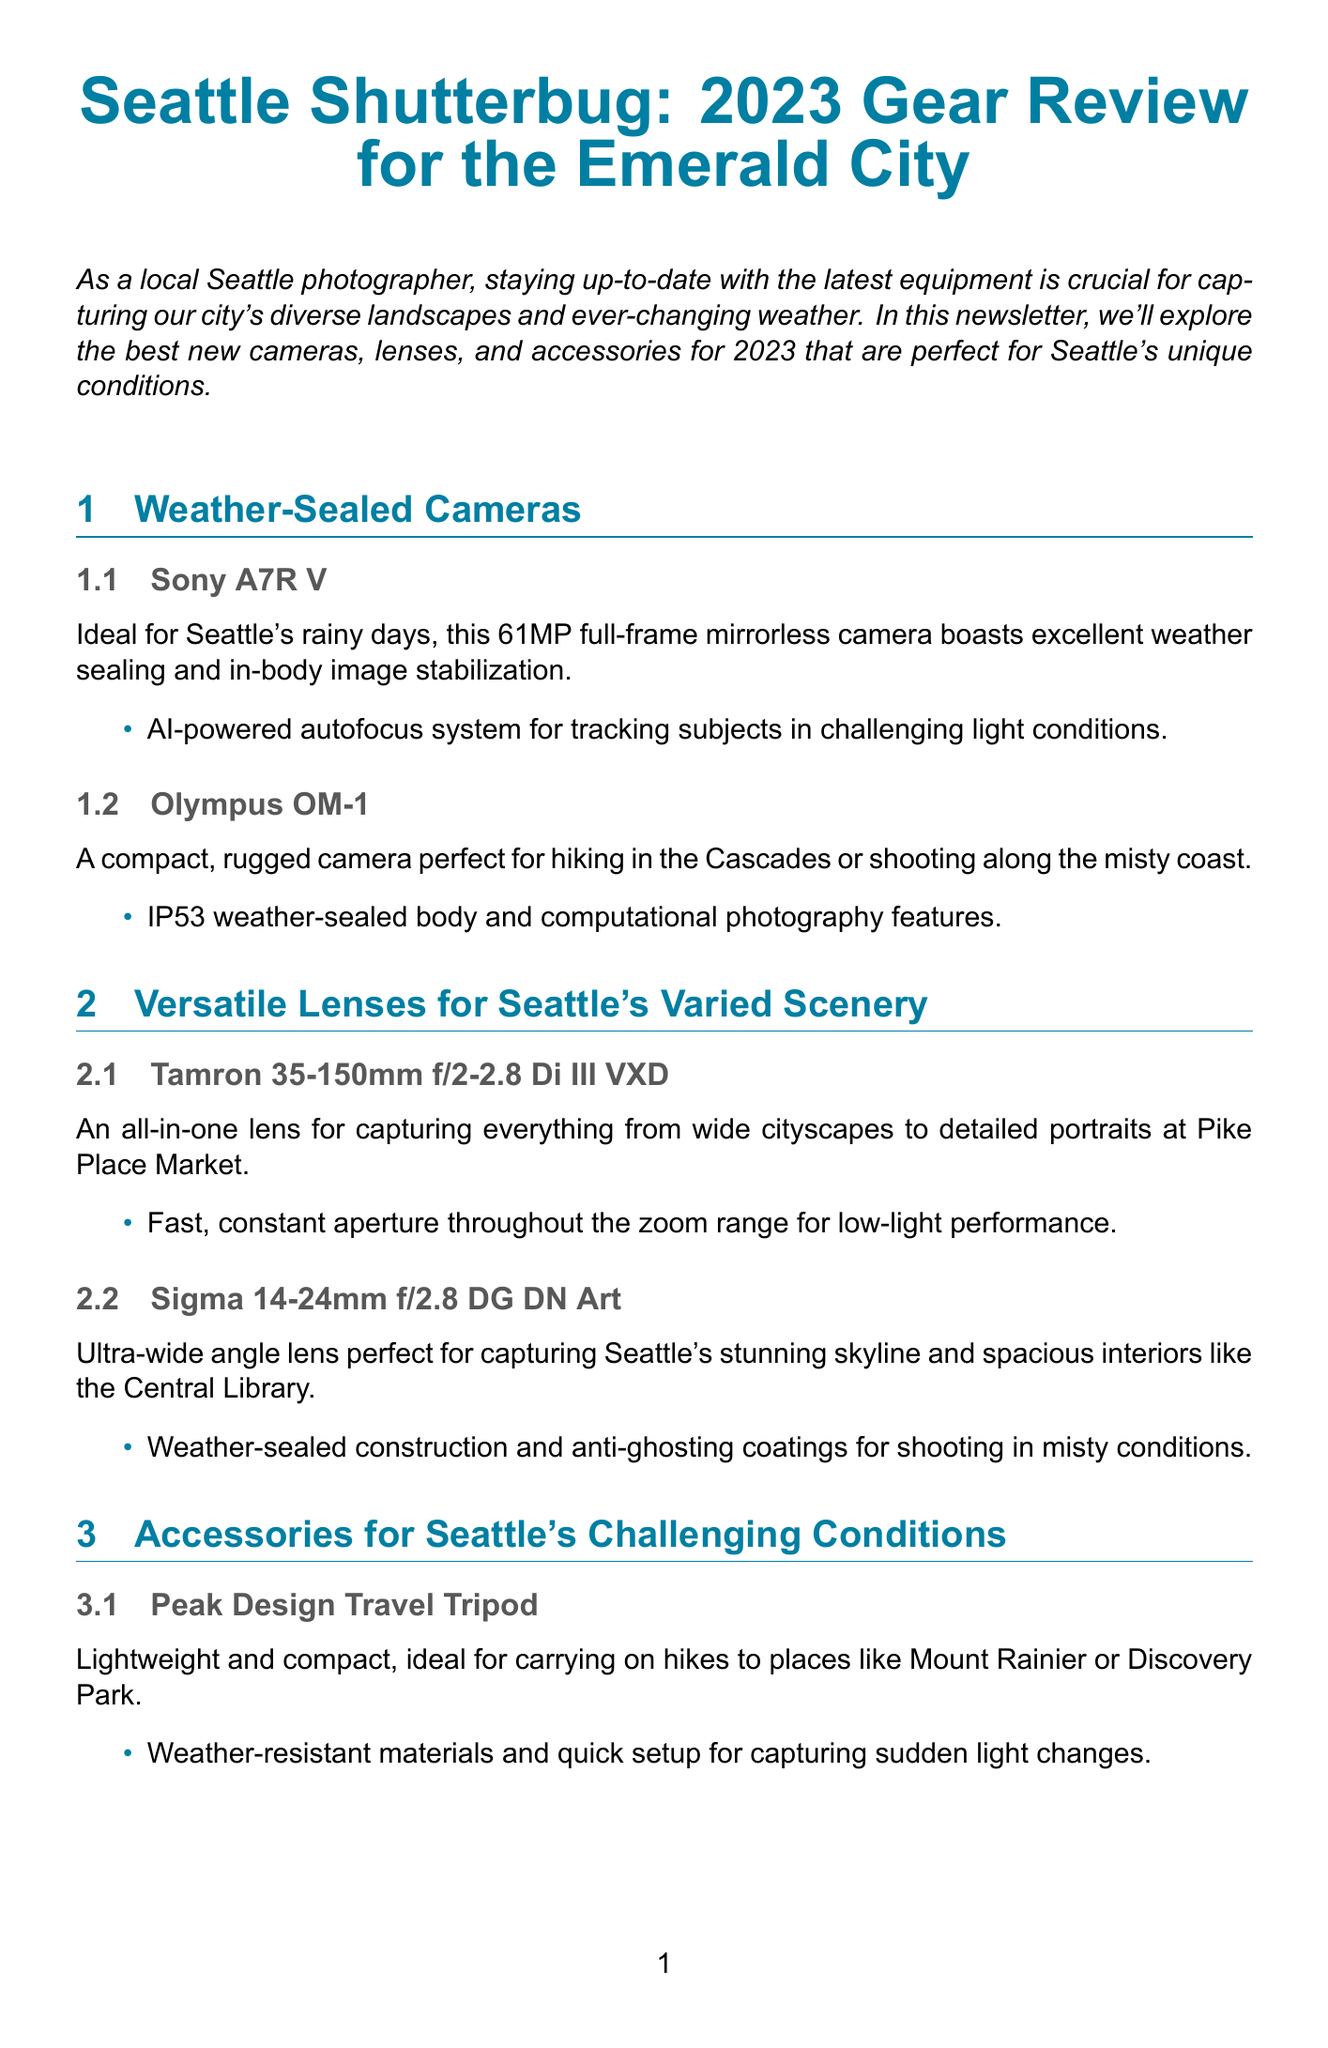What is the title of the newsletter? The title of the newsletter is provided at the top and introduces the main subject, which is "Seattle Shutterbug: 2023 Gear Review for the Emerald City."
Answer: Seattle Shutterbug: 2023 Gear Review for the Emerald City How many weather-sealed cameras are featured? The document lists two specific weather-sealed cameras under the "Weather-Sealed Cameras" section.
Answer: 2 What is a key feature of the Sony A7R V? The key feature of the Sony A7R V is mentioned in the description section, highlighting its AI-powered autofocus system.
Answer: AI-powered autofocus system What type of photography accessory is the Lenscoat RainCoat RS? The document describes this item under accessories, specifically stating it is essential protection for cameras during rain.
Answer: camera protection Which lens is recommended for low-light photography? The document lists the Profoto B10X Plus as a portable studio light aimed for low-light conditions.
Answer: Profoto B10X Plus What city’s photography environments are the reviewed products tailored for? The newsletter specifies that the equipment is ideal for the diverse conditions of Seattle.
Answer: Seattle How does the DJI Air 2S Drone enhance aerial photography? The document states that it features a 1-inch CMOS sensor and obstacle avoidance, enhancing its use in urban areas.
Answer: 1-inch CMOS sensor and obstacle avoidance Which camera is described as compact and rugged? The description of the Olympus OM-1 highlights its compact and rugged design for outdoor use.
Answer: Olympus OM-1 